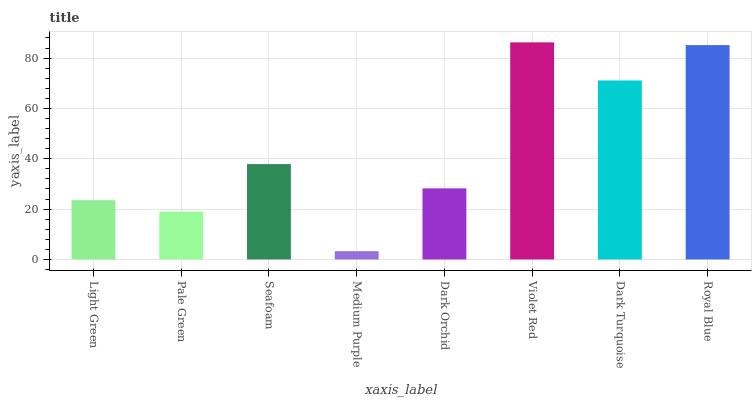Is Medium Purple the minimum?
Answer yes or no. Yes. Is Violet Red the maximum?
Answer yes or no. Yes. Is Pale Green the minimum?
Answer yes or no. No. Is Pale Green the maximum?
Answer yes or no. No. Is Light Green greater than Pale Green?
Answer yes or no. Yes. Is Pale Green less than Light Green?
Answer yes or no. Yes. Is Pale Green greater than Light Green?
Answer yes or no. No. Is Light Green less than Pale Green?
Answer yes or no. No. Is Seafoam the high median?
Answer yes or no. Yes. Is Dark Orchid the low median?
Answer yes or no. Yes. Is Violet Red the high median?
Answer yes or no. No. Is Dark Turquoise the low median?
Answer yes or no. No. 